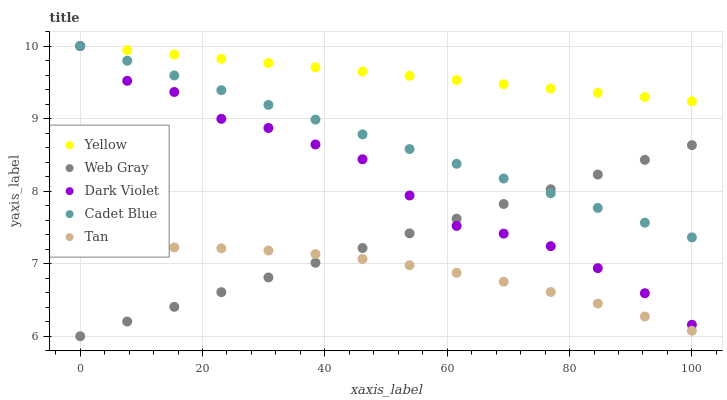Does Tan have the minimum area under the curve?
Answer yes or no. Yes. Does Yellow have the maximum area under the curve?
Answer yes or no. Yes. Does Web Gray have the minimum area under the curve?
Answer yes or no. No. Does Web Gray have the maximum area under the curve?
Answer yes or no. No. Is Yellow the smoothest?
Answer yes or no. Yes. Is Dark Violet the roughest?
Answer yes or no. Yes. Is Tan the smoothest?
Answer yes or no. No. Is Tan the roughest?
Answer yes or no. No. Does Web Gray have the lowest value?
Answer yes or no. Yes. Does Tan have the lowest value?
Answer yes or no. No. Does Yellow have the highest value?
Answer yes or no. Yes. Does Web Gray have the highest value?
Answer yes or no. No. Is Tan less than Cadet Blue?
Answer yes or no. Yes. Is Yellow greater than Web Gray?
Answer yes or no. Yes. Does Dark Violet intersect Web Gray?
Answer yes or no. Yes. Is Dark Violet less than Web Gray?
Answer yes or no. No. Is Dark Violet greater than Web Gray?
Answer yes or no. No. Does Tan intersect Cadet Blue?
Answer yes or no. No. 